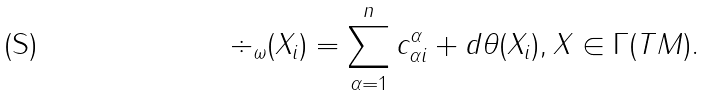Convert formula to latex. <formula><loc_0><loc_0><loc_500><loc_500>\div _ { \omega } ( X _ { i } ) = \sum _ { \alpha = 1 } ^ { n } c _ { \alpha i } ^ { \alpha } + d \theta ( X _ { i } ) , X \in \Gamma ( T M ) .</formula> 